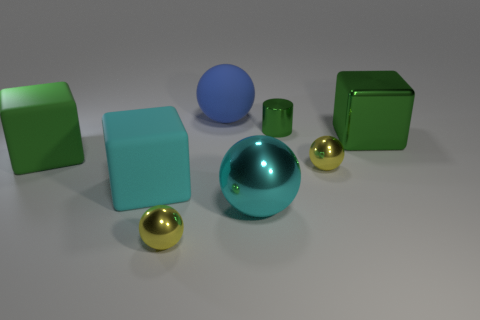Subtract all red spheres. Subtract all blue cylinders. How many spheres are left? 4 Add 1 small yellow metal spheres. How many objects exist? 9 Subtract all cubes. How many objects are left? 5 Subtract 0 green spheres. How many objects are left? 8 Subtract all large yellow metallic cylinders. Subtract all small shiny cylinders. How many objects are left? 7 Add 5 metal spheres. How many metal spheres are left? 8 Add 4 tiny green things. How many tiny green things exist? 5 